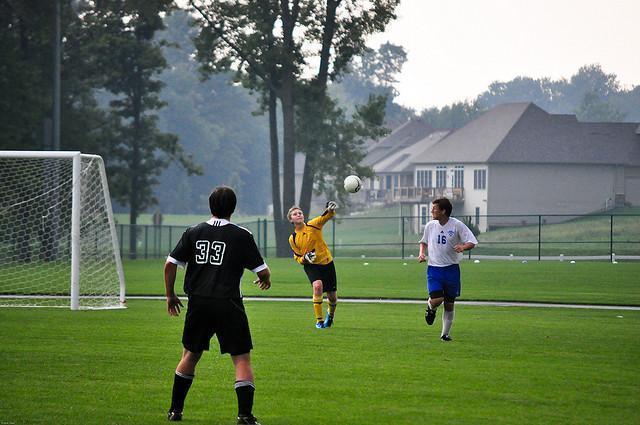Why is the one guy wearing a yellow uniform?
Answer the question by selecting the correct answer among the 4 following choices.
Options: Spectator, referee, water boy, goalie. Goalie. 